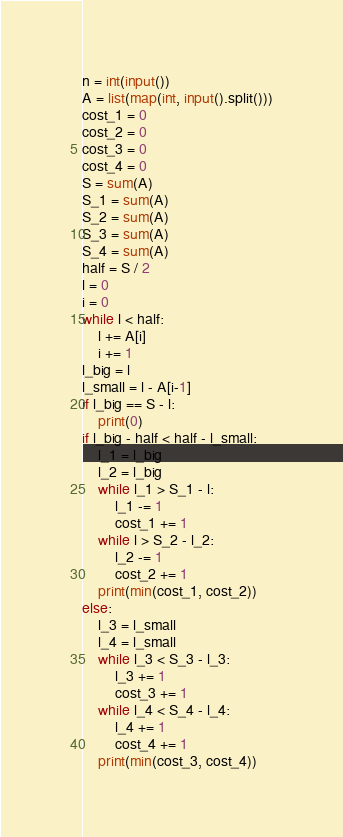Convert code to text. <code><loc_0><loc_0><loc_500><loc_500><_Python_>n = int(input())
A = list(map(int, input().split()))
cost_1 = 0
cost_2 = 0
cost_3 = 0
cost_4 = 0
S = sum(A)
S_1 = sum(A)
S_2 = sum(A)
S_3 = sum(A)
S_4 = sum(A)
half = S / 2
l = 0
i = 0
while l < half:
    l += A[i]
    i += 1
l_big = l
l_small = l - A[i-1]
if l_big == S - l:
    print(0)
if l_big - half < half - l_small:
    l_1 = l_big
    l_2 = l_big
    while l_1 > S_1 - l:
        l_1 -= 1
        cost_1 += 1
    while l > S_2 - l_2:
        l_2 -= 1
        cost_2 += 1
    print(min(cost_1, cost_2))
else:
    l_3 = l_small
    l_4 = l_small
    while l_3 < S_3 - l_3:
        l_3 += 1
        cost_3 += 1
    while l_4 < S_4 - l_4:
        l_4 += 1
        cost_4 += 1
    print(min(cost_3, cost_4))</code> 